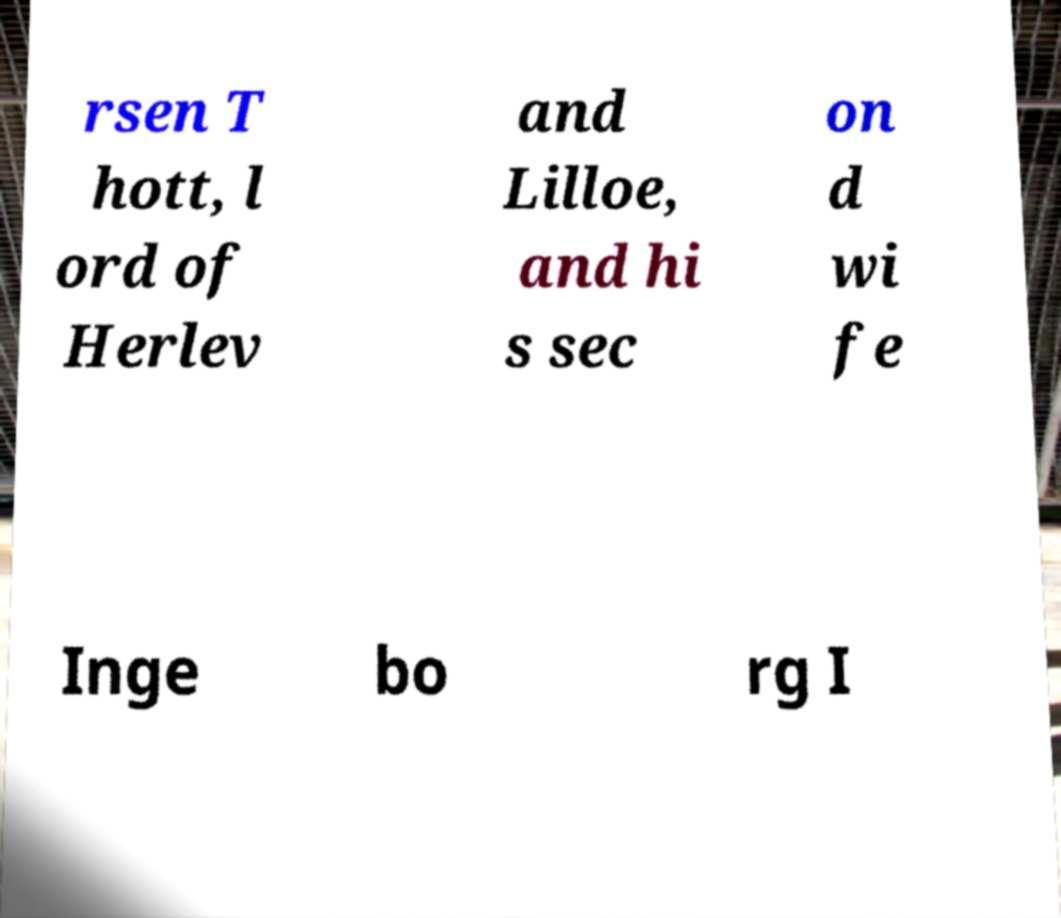What messages or text are displayed in this image? I need them in a readable, typed format. rsen T hott, l ord of Herlev and Lilloe, and hi s sec on d wi fe Inge bo rg I 